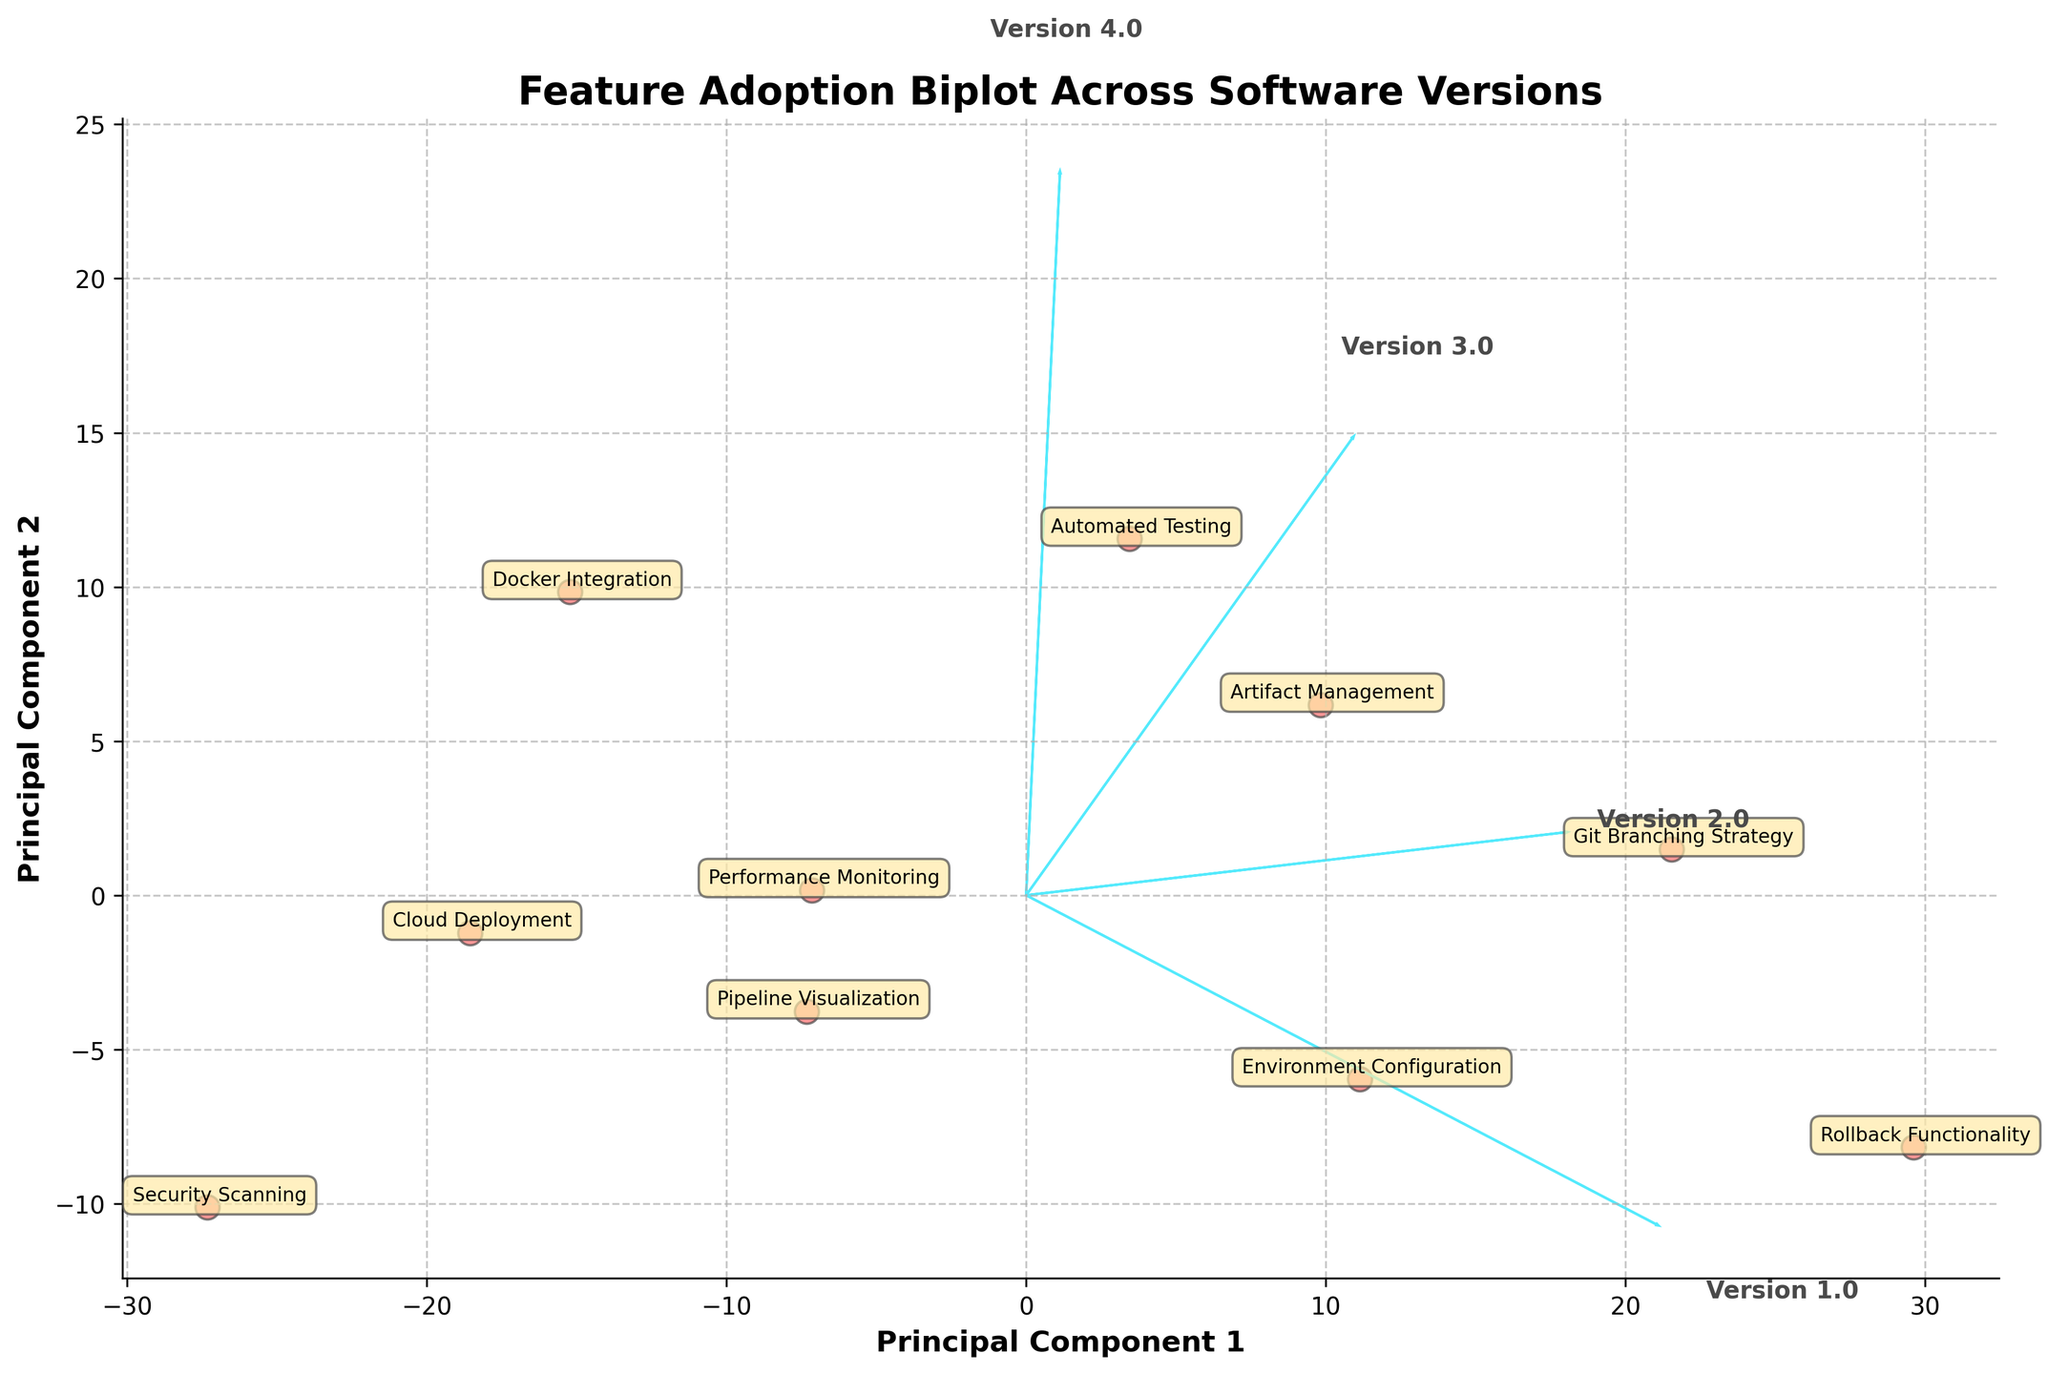what is the title of the figure? The title is usually displayed at the top of the plot in a larger or bold font, making it easy to identify. The title helps in understanding the overall theme of the figure.
Answer: Feature Adoption Biplot Across Software Versions What are the labels of the principal components on the axes? The labels are shown along the x-axis and y-axis to denote the principal components calculated during PCA. They help in understanding which components are being compared in the biplot.
Answer: Principal Component 1 and Principal Component 2 How many features are represented in the biplot? The plot visually represents data points corresponding to the different features. Each data point on the biplot is annotated with the feature name, allowing us to count them. Count the number of annotated names.
Answer: 10 Which feature shows the highest progression from Version 1.0 to Version 4.0? By examining the directional spread and density of the data points annotated with different features, we can identify which feature exhibits the highest progression in adoption. Look for the feature that shows an upward or rightward trajectory from Version 1.0 to Version 4.0.
Answer: Automated Testing Between 'Docker Integration' and 'Performance Monitoring,' which feature has a higher contribution in the first principal component? The contribution of features in the principal component can be inferred by the relative positioning of data points along the axis of the first principal component. Compare the positions of 'Docker Integration' and 'Performance Monitoring' along the Principal Component 1 axis.
Answer: Docker Integration Which version contributes the most along the second principal component? Arrows representing software versions point in certain directions, illustrating their contribution to the principal components. Identify which arrow extends the most along the y-axis to determine the largest contribution to the second principal component.
Answer: Version 4.0 Is there any feature that shows low adoption rates consistently across all versions? Features with low adoption rates in all versions would be located near the origin and possibly in the lower-left quadrant of the biplot. Look for features whose points are closer to the lower-left area.
Answer: Security Scanning How does 'Git Branching Strategy' compare to the 'Environment Configuration' feature in terms of adoption rates progression? Check the relative position and distance of 'Git Branching Strategy' and 'Environment Configuration' data points across the principal components to see their adoption trend. Note the movement and spread of these features from different versions.
Answer: Git Branching Strategy shows higher progression than Environment Configuration What can be inferred about the adoption trend of 'Rollback Functionality'? By closely observing the position and spread of 'Rollback Functionality,' we can deduce its overall adoption trend across different software versions. Note any consistent upward or rightward shift for this feature.
Answer: It shows consistent, moderate progression across versions Which feature is closest to 'Principal Component 1'? Determine which feature's data point is nearest to the x-axis aligned with Principal Component 1, indicating a significant contribution to this component.
Answer: Performance Monitoring 